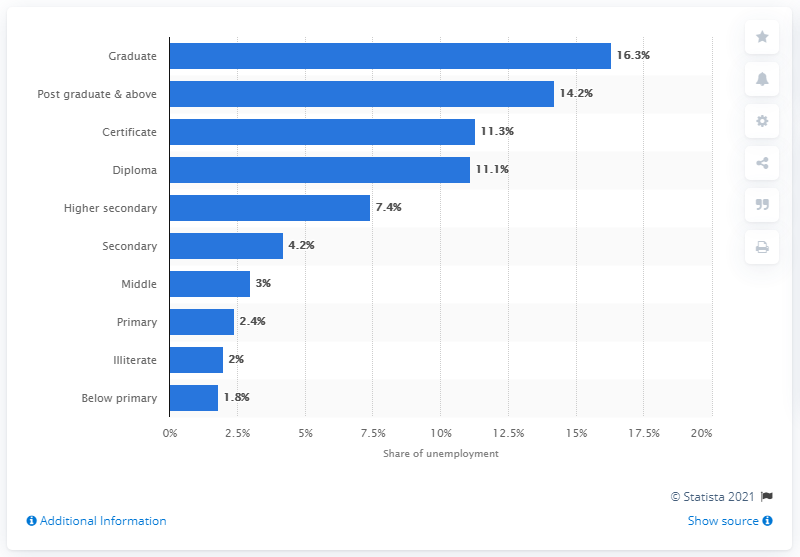List a handful of essential elements in this visual. In 2019, the highest unemployment rate was recorded among graduates, with 16.3% of them experiencing joblessness. According to data from 2019, the share of postgraduate students with the highest unemployment rate was 14.2%. Educational qualifications with a minimum share in unemployment are those below primary level. The total sum of the unemployment share of graduates and diploma holders is 27.4%. 